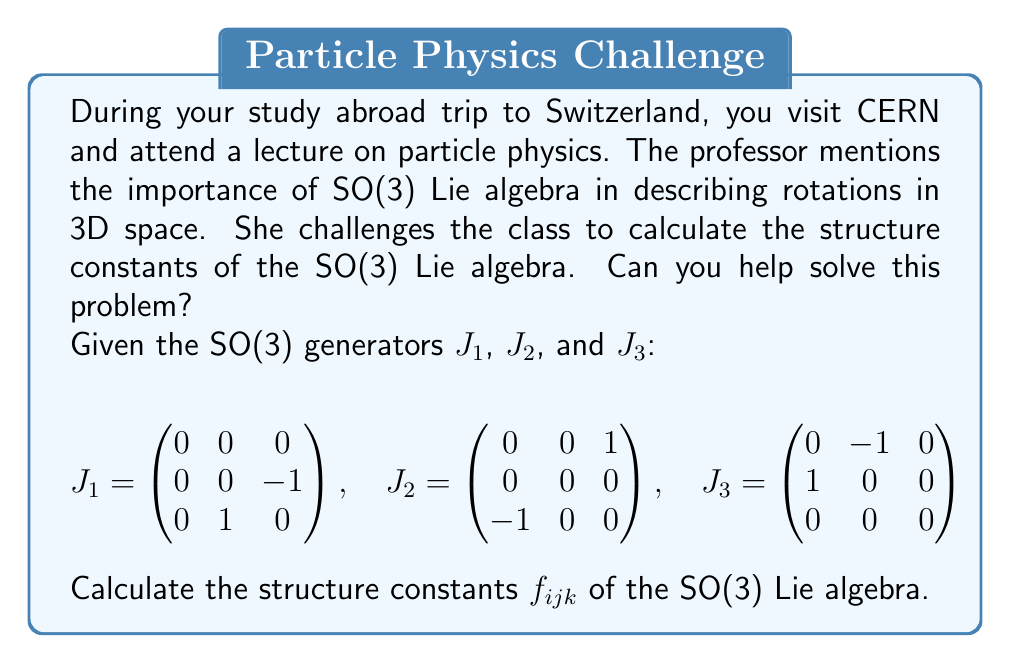Help me with this question. To calculate the structure constants of the SO(3) Lie algebra, we need to follow these steps:

1) The structure constants $f_{ijk}$ are defined by the commutation relations:

   $$[J_i, J_j] = \sum_{k=1}^3 f_{ijk} J_k$$

2) We need to compute the commutators $[J_1, J_2]$, $[J_2, J_3]$, and $[J_3, J_1]$:

   $[J_1, J_2] = J_1J_2 - J_2J_1 = \begin{pmatrix}
   0 & 0 & 0 \\
   1 & 0 & 0 \\
   0 & 0 & 0
   \end{pmatrix} = J_3$

   $[J_2, J_3] = J_2J_3 - J_3J_2 = \begin{pmatrix}
   0 & 0 & 0 \\
   0 & 0 & 1 \\
   0 & 0 & 0
   \end{pmatrix} = J_1$

   $[J_3, J_1] = J_3J_1 - J_1J_3 = \begin{pmatrix}
   0 & 0 & 1 \\
   0 & 0 & 0 \\
   0 & 0 & 0
   \end{pmatrix} = J_2$

3) From these results, we can identify the non-zero structure constants:

   $[J_1, J_2] = J_3$ implies $f_{123} = 1$
   $[J_2, J_3] = J_1$ implies $f_{231} = 1$
   $[J_3, J_1] = J_2$ implies $f_{312} = 1$

4) The structure constants are antisymmetric in the first two indices, so:

   $f_{213} = -f_{123} = -1$
   $f_{321} = -f_{231} = -1$
   $f_{132} = -f_{312} = -1$

5) All other structure constants are zero.
Answer: $f_{123} = f_{231} = f_{312} = 1$, $f_{213} = f_{321} = f_{132} = -1$, all others $= 0$ 